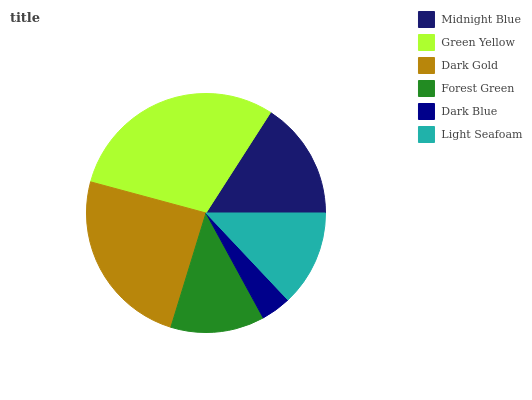Is Dark Blue the minimum?
Answer yes or no. Yes. Is Green Yellow the maximum?
Answer yes or no. Yes. Is Dark Gold the minimum?
Answer yes or no. No. Is Dark Gold the maximum?
Answer yes or no. No. Is Green Yellow greater than Dark Gold?
Answer yes or no. Yes. Is Dark Gold less than Green Yellow?
Answer yes or no. Yes. Is Dark Gold greater than Green Yellow?
Answer yes or no. No. Is Green Yellow less than Dark Gold?
Answer yes or no. No. Is Midnight Blue the high median?
Answer yes or no. Yes. Is Light Seafoam the low median?
Answer yes or no. Yes. Is Forest Green the high median?
Answer yes or no. No. Is Forest Green the low median?
Answer yes or no. No. 